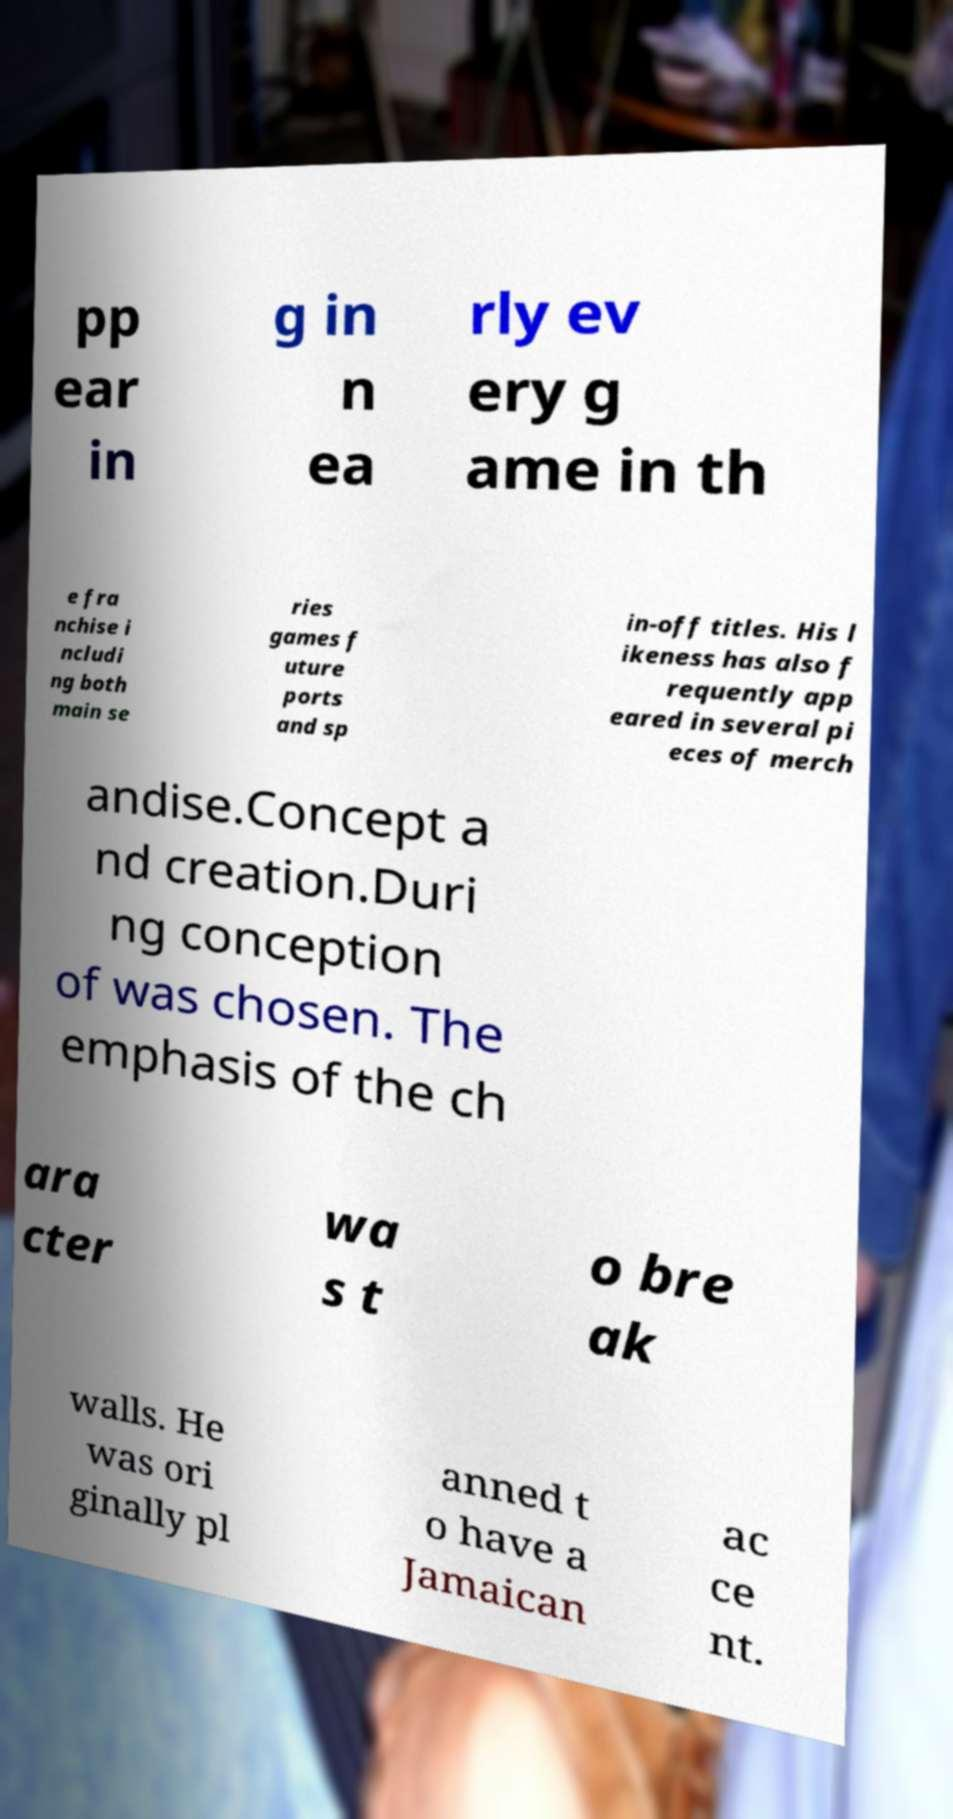Can you accurately transcribe the text from the provided image for me? pp ear in g in n ea rly ev ery g ame in th e fra nchise i ncludi ng both main se ries games f uture ports and sp in-off titles. His l ikeness has also f requently app eared in several pi eces of merch andise.Concept a nd creation.Duri ng conception of was chosen. The emphasis of the ch ara cter wa s t o bre ak walls. He was ori ginally pl anned t o have a Jamaican ac ce nt. 